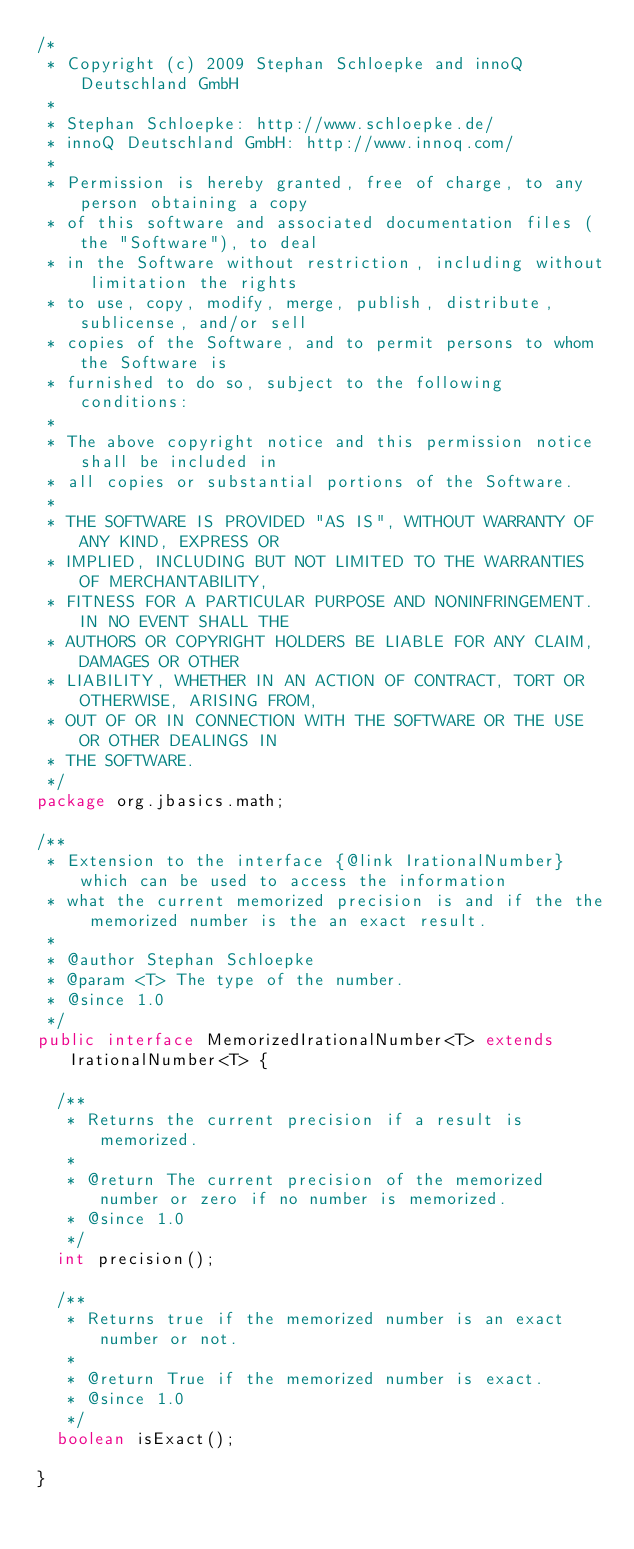<code> <loc_0><loc_0><loc_500><loc_500><_Java_>/*
 * Copyright (c) 2009 Stephan Schloepke and innoQ Deutschland GmbH
 *
 * Stephan Schloepke: http://www.schloepke.de/
 * innoQ Deutschland GmbH: http://www.innoq.com/
 *
 * Permission is hereby granted, free of charge, to any person obtaining a copy
 * of this software and associated documentation files (the "Software"), to deal
 * in the Software without restriction, including without limitation the rights
 * to use, copy, modify, merge, publish, distribute, sublicense, and/or sell
 * copies of the Software, and to permit persons to whom the Software is
 * furnished to do so, subject to the following conditions:
 *
 * The above copyright notice and this permission notice shall be included in
 * all copies or substantial portions of the Software.
 *
 * THE SOFTWARE IS PROVIDED "AS IS", WITHOUT WARRANTY OF ANY KIND, EXPRESS OR
 * IMPLIED, INCLUDING BUT NOT LIMITED TO THE WARRANTIES OF MERCHANTABILITY,
 * FITNESS FOR A PARTICULAR PURPOSE AND NONINFRINGEMENT. IN NO EVENT SHALL THE
 * AUTHORS OR COPYRIGHT HOLDERS BE LIABLE FOR ANY CLAIM, DAMAGES OR OTHER
 * LIABILITY, WHETHER IN AN ACTION OF CONTRACT, TORT OR OTHERWISE, ARISING FROM,
 * OUT OF OR IN CONNECTION WITH THE SOFTWARE OR THE USE OR OTHER DEALINGS IN
 * THE SOFTWARE.
 */
package org.jbasics.math;

/**
 * Extension to the interface {@link IrationalNumber} which can be used to access the information
 * what the current memorized precision is and if the the memorized number is the an exact result.
 * 
 * @author Stephan Schloepke
 * @param <T> The type of the number.
 * @since 1.0
 */
public interface MemorizedIrationalNumber<T> extends IrationalNumber<T> {

	/**
	 * Returns the current precision if a result is memorized.
	 * 
	 * @return The current precision of the memorized number or zero if no number is memorized.
	 * @since 1.0
	 */
	int precision();

	/**
	 * Returns true if the memorized number is an exact number or not.
	 * 
	 * @return True if the memorized number is exact.
	 * @since 1.0
	 */
	boolean isExact();

}
</code> 